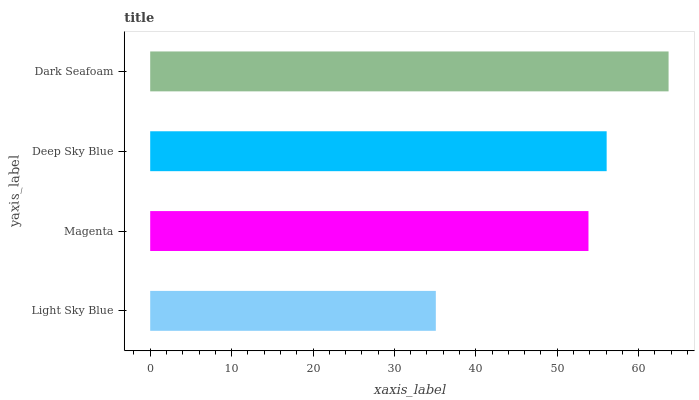Is Light Sky Blue the minimum?
Answer yes or no. Yes. Is Dark Seafoam the maximum?
Answer yes or no. Yes. Is Magenta the minimum?
Answer yes or no. No. Is Magenta the maximum?
Answer yes or no. No. Is Magenta greater than Light Sky Blue?
Answer yes or no. Yes. Is Light Sky Blue less than Magenta?
Answer yes or no. Yes. Is Light Sky Blue greater than Magenta?
Answer yes or no. No. Is Magenta less than Light Sky Blue?
Answer yes or no. No. Is Deep Sky Blue the high median?
Answer yes or no. Yes. Is Magenta the low median?
Answer yes or no. Yes. Is Light Sky Blue the high median?
Answer yes or no. No. Is Dark Seafoam the low median?
Answer yes or no. No. 